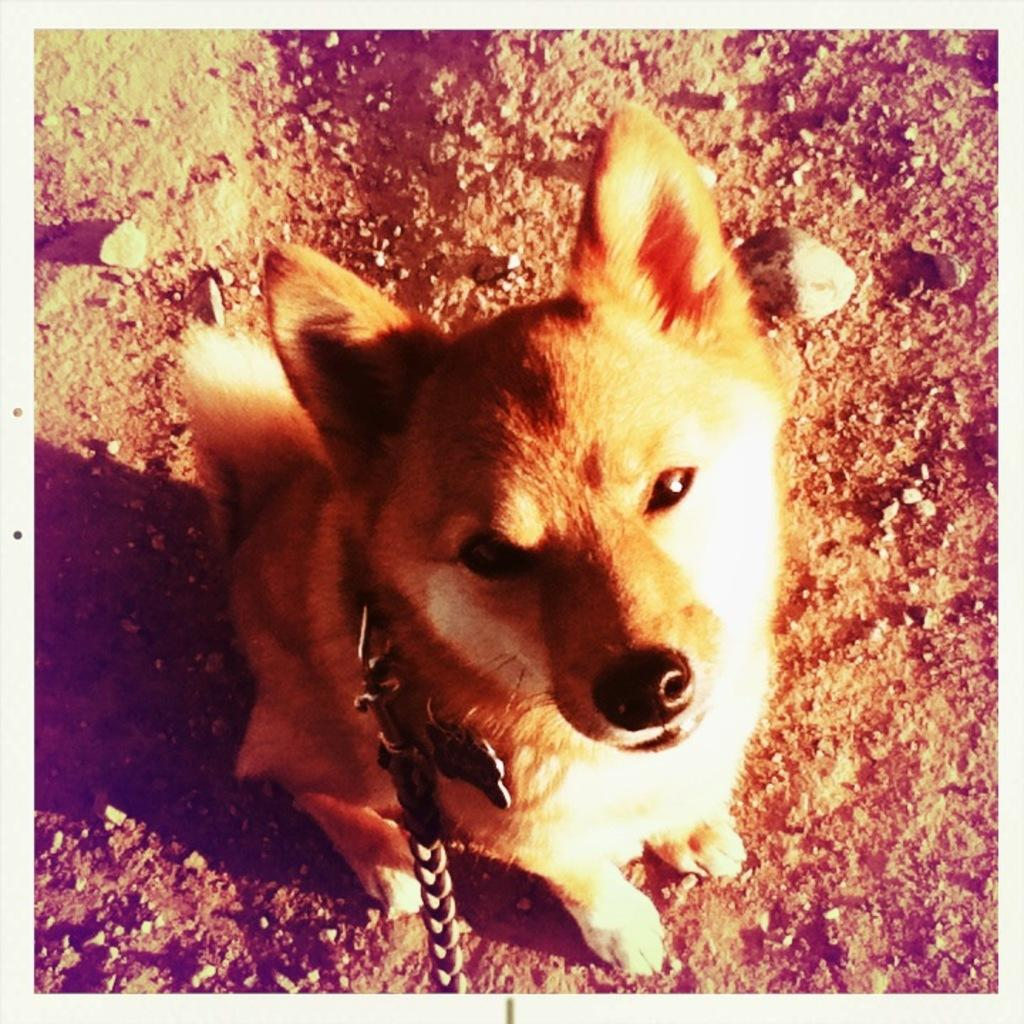What animal can be seen in the picture? There is a dog in the picture. How is the dog restrained in the image? The dog is tied with a chain. What type of grape is the dog eating in the picture? There is no grape present in the image, and the dog is not eating anything. How does the dog's memory affect its behavior in the picture? The dog's memory is not mentioned or depicted in the image, so it cannot be determined how it affects its behavior. 